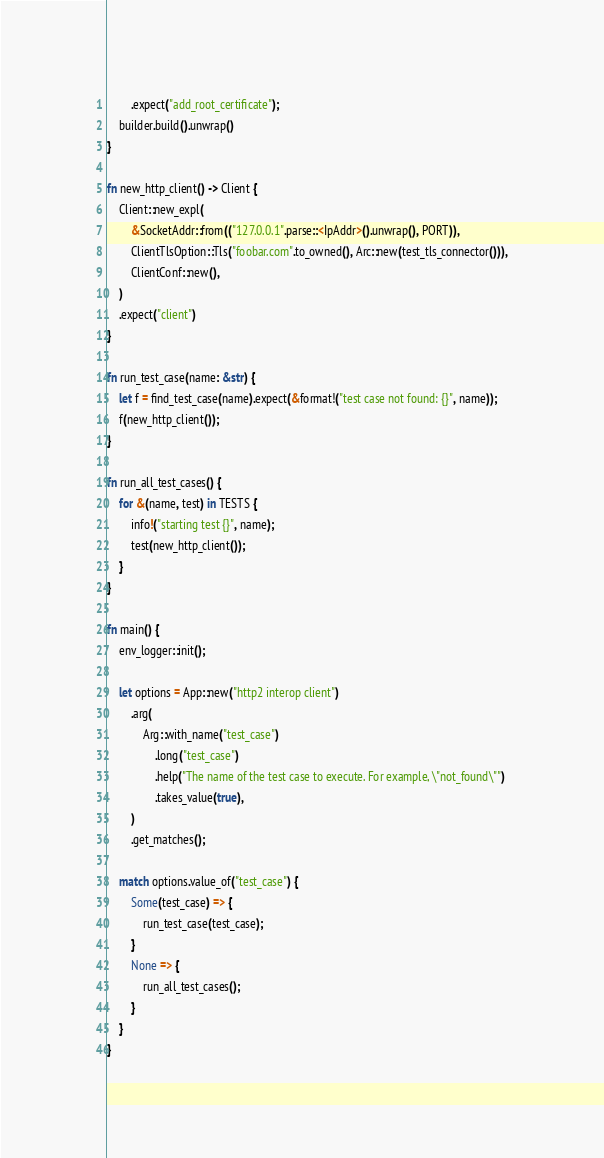<code> <loc_0><loc_0><loc_500><loc_500><_Rust_>        .expect("add_root_certificate");
    builder.build().unwrap()
}

fn new_http_client() -> Client {
    Client::new_expl(
        &SocketAddr::from(("127.0.0.1".parse::<IpAddr>().unwrap(), PORT)),
        ClientTlsOption::Tls("foobar.com".to_owned(), Arc::new(test_tls_connector())),
        ClientConf::new(),
    )
    .expect("client")
}

fn run_test_case(name: &str) {
    let f = find_test_case(name).expect(&format!("test case not found: {}", name));
    f(new_http_client());
}

fn run_all_test_cases() {
    for &(name, test) in TESTS {
        info!("starting test {}", name);
        test(new_http_client());
    }
}

fn main() {
    env_logger::init();

    let options = App::new("http2 interop client")
        .arg(
            Arg::with_name("test_case")
                .long("test_case")
                .help("The name of the test case to execute. For example, \"not_found\"")
                .takes_value(true),
        )
        .get_matches();

    match options.value_of("test_case") {
        Some(test_case) => {
            run_test_case(test_case);
        }
        None => {
            run_all_test_cases();
        }
    }
}
</code> 